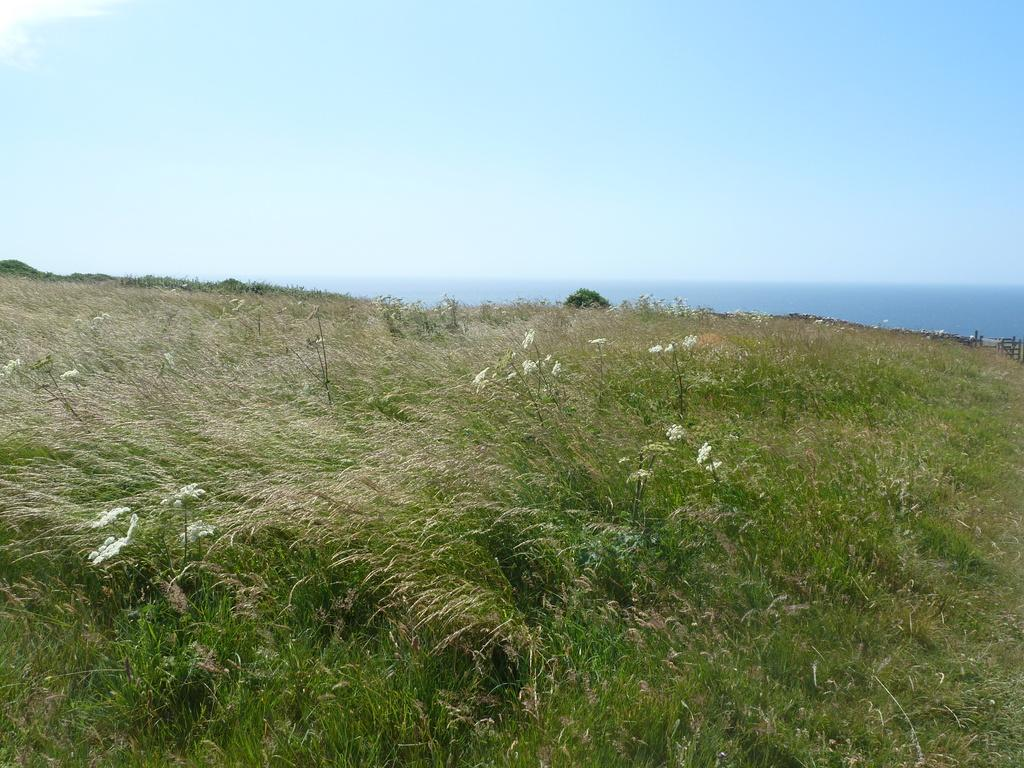What can be seen in the background of the image? The sky is visible in the image. What type of vegetation is present in the image? There are plants and grass visible in the image. What additional features can be observed among the vegetation? Flowers are visible in the image. What type of machine is visible in the image? There is no machine present in the image; it features the sky, plants, grass, and flowers. 